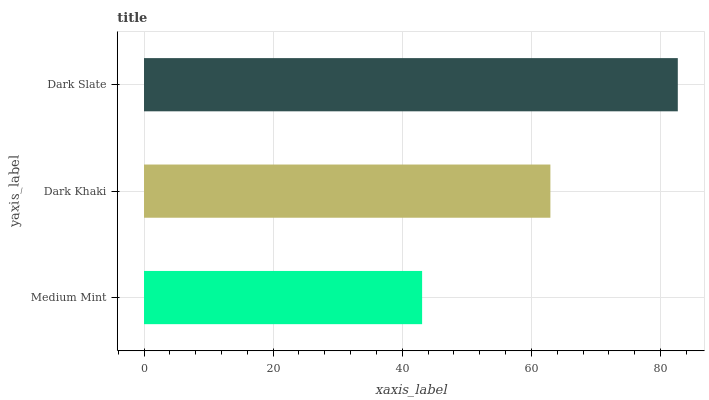Is Medium Mint the minimum?
Answer yes or no. Yes. Is Dark Slate the maximum?
Answer yes or no. Yes. Is Dark Khaki the minimum?
Answer yes or no. No. Is Dark Khaki the maximum?
Answer yes or no. No. Is Dark Khaki greater than Medium Mint?
Answer yes or no. Yes. Is Medium Mint less than Dark Khaki?
Answer yes or no. Yes. Is Medium Mint greater than Dark Khaki?
Answer yes or no. No. Is Dark Khaki less than Medium Mint?
Answer yes or no. No. Is Dark Khaki the high median?
Answer yes or no. Yes. Is Dark Khaki the low median?
Answer yes or no. Yes. Is Medium Mint the high median?
Answer yes or no. No. Is Medium Mint the low median?
Answer yes or no. No. 